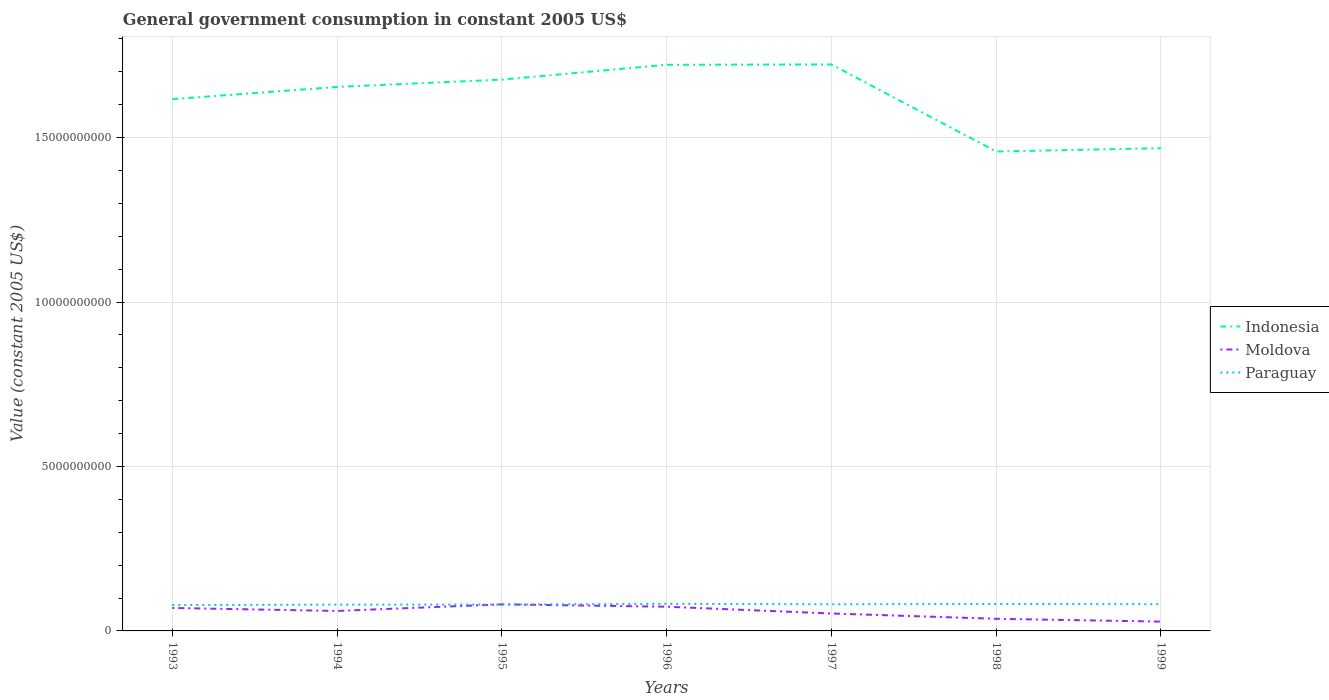How many different coloured lines are there?
Your answer should be compact. 3. Across all years, what is the maximum government conusmption in Moldova?
Give a very brief answer. 2.83e+08. In which year was the government conusmption in Indonesia maximum?
Ensure brevity in your answer.  1998. What is the total government conusmption in Indonesia in the graph?
Provide a succinct answer. -5.95e+08. What is the difference between the highest and the second highest government conusmption in Paraguay?
Keep it short and to the point. 3.76e+07. How many legend labels are there?
Give a very brief answer. 3. What is the title of the graph?
Make the answer very short. General government consumption in constant 2005 US$. Does "South Sudan" appear as one of the legend labels in the graph?
Keep it short and to the point. No. What is the label or title of the X-axis?
Your answer should be compact. Years. What is the label or title of the Y-axis?
Keep it short and to the point. Value (constant 2005 US$). What is the Value (constant 2005 US$) in Indonesia in 1993?
Your answer should be compact. 1.62e+1. What is the Value (constant 2005 US$) in Moldova in 1993?
Provide a short and direct response. 6.98e+08. What is the Value (constant 2005 US$) in Paraguay in 1993?
Provide a short and direct response. 7.86e+08. What is the Value (constant 2005 US$) of Indonesia in 1994?
Provide a short and direct response. 1.65e+1. What is the Value (constant 2005 US$) of Moldova in 1994?
Offer a terse response. 6.08e+08. What is the Value (constant 2005 US$) of Paraguay in 1994?
Your answer should be very brief. 8.00e+08. What is the Value (constant 2005 US$) in Indonesia in 1995?
Make the answer very short. 1.68e+1. What is the Value (constant 2005 US$) in Moldova in 1995?
Offer a very short reply. 8.07e+08. What is the Value (constant 2005 US$) of Paraguay in 1995?
Offer a terse response. 8.02e+08. What is the Value (constant 2005 US$) of Indonesia in 1996?
Make the answer very short. 1.72e+1. What is the Value (constant 2005 US$) in Moldova in 1996?
Your answer should be compact. 7.36e+08. What is the Value (constant 2005 US$) in Paraguay in 1996?
Your answer should be compact. 8.23e+08. What is the Value (constant 2005 US$) of Indonesia in 1997?
Offer a terse response. 1.72e+1. What is the Value (constant 2005 US$) of Moldova in 1997?
Your response must be concise. 5.30e+08. What is the Value (constant 2005 US$) of Paraguay in 1997?
Your answer should be compact. 8.10e+08. What is the Value (constant 2005 US$) of Indonesia in 1998?
Provide a short and direct response. 1.46e+1. What is the Value (constant 2005 US$) of Moldova in 1998?
Make the answer very short. 3.69e+08. What is the Value (constant 2005 US$) in Paraguay in 1998?
Give a very brief answer. 8.19e+08. What is the Value (constant 2005 US$) of Indonesia in 1999?
Offer a very short reply. 1.47e+1. What is the Value (constant 2005 US$) of Moldova in 1999?
Ensure brevity in your answer.  2.83e+08. What is the Value (constant 2005 US$) of Paraguay in 1999?
Ensure brevity in your answer.  8.12e+08. Across all years, what is the maximum Value (constant 2005 US$) in Indonesia?
Offer a very short reply. 1.72e+1. Across all years, what is the maximum Value (constant 2005 US$) in Moldova?
Provide a short and direct response. 8.07e+08. Across all years, what is the maximum Value (constant 2005 US$) of Paraguay?
Offer a very short reply. 8.23e+08. Across all years, what is the minimum Value (constant 2005 US$) of Indonesia?
Give a very brief answer. 1.46e+1. Across all years, what is the minimum Value (constant 2005 US$) in Moldova?
Keep it short and to the point. 2.83e+08. Across all years, what is the minimum Value (constant 2005 US$) of Paraguay?
Your answer should be compact. 7.86e+08. What is the total Value (constant 2005 US$) of Indonesia in the graph?
Offer a very short reply. 1.13e+11. What is the total Value (constant 2005 US$) of Moldova in the graph?
Offer a terse response. 4.03e+09. What is the total Value (constant 2005 US$) of Paraguay in the graph?
Give a very brief answer. 5.65e+09. What is the difference between the Value (constant 2005 US$) in Indonesia in 1993 and that in 1994?
Provide a short and direct response. -3.73e+08. What is the difference between the Value (constant 2005 US$) of Moldova in 1993 and that in 1994?
Your answer should be compact. 9.04e+07. What is the difference between the Value (constant 2005 US$) of Paraguay in 1993 and that in 1994?
Your answer should be very brief. -1.39e+07. What is the difference between the Value (constant 2005 US$) in Indonesia in 1993 and that in 1995?
Your response must be concise. -5.95e+08. What is the difference between the Value (constant 2005 US$) of Moldova in 1993 and that in 1995?
Offer a terse response. -1.09e+08. What is the difference between the Value (constant 2005 US$) of Paraguay in 1993 and that in 1995?
Your answer should be compact. -1.62e+07. What is the difference between the Value (constant 2005 US$) in Indonesia in 1993 and that in 1996?
Make the answer very short. -1.05e+09. What is the difference between the Value (constant 2005 US$) of Moldova in 1993 and that in 1996?
Your response must be concise. -3.82e+07. What is the difference between the Value (constant 2005 US$) of Paraguay in 1993 and that in 1996?
Make the answer very short. -3.76e+07. What is the difference between the Value (constant 2005 US$) in Indonesia in 1993 and that in 1997?
Keep it short and to the point. -1.06e+09. What is the difference between the Value (constant 2005 US$) of Moldova in 1993 and that in 1997?
Keep it short and to the point. 1.68e+08. What is the difference between the Value (constant 2005 US$) of Paraguay in 1993 and that in 1997?
Your answer should be compact. -2.44e+07. What is the difference between the Value (constant 2005 US$) in Indonesia in 1993 and that in 1998?
Offer a very short reply. 1.59e+09. What is the difference between the Value (constant 2005 US$) in Moldova in 1993 and that in 1998?
Ensure brevity in your answer.  3.29e+08. What is the difference between the Value (constant 2005 US$) of Paraguay in 1993 and that in 1998?
Provide a short and direct response. -3.36e+07. What is the difference between the Value (constant 2005 US$) of Indonesia in 1993 and that in 1999?
Ensure brevity in your answer.  1.49e+09. What is the difference between the Value (constant 2005 US$) in Moldova in 1993 and that in 1999?
Ensure brevity in your answer.  4.15e+08. What is the difference between the Value (constant 2005 US$) of Paraguay in 1993 and that in 1999?
Offer a terse response. -2.66e+07. What is the difference between the Value (constant 2005 US$) in Indonesia in 1994 and that in 1995?
Your response must be concise. -2.22e+08. What is the difference between the Value (constant 2005 US$) of Moldova in 1994 and that in 1995?
Your response must be concise. -2.00e+08. What is the difference between the Value (constant 2005 US$) in Paraguay in 1994 and that in 1995?
Your answer should be compact. -2.36e+06. What is the difference between the Value (constant 2005 US$) in Indonesia in 1994 and that in 1996?
Make the answer very short. -6.73e+08. What is the difference between the Value (constant 2005 US$) in Moldova in 1994 and that in 1996?
Provide a short and direct response. -1.29e+08. What is the difference between the Value (constant 2005 US$) in Paraguay in 1994 and that in 1996?
Your response must be concise. -2.37e+07. What is the difference between the Value (constant 2005 US$) of Indonesia in 1994 and that in 1997?
Keep it short and to the point. -6.84e+08. What is the difference between the Value (constant 2005 US$) in Moldova in 1994 and that in 1997?
Provide a succinct answer. 7.75e+07. What is the difference between the Value (constant 2005 US$) of Paraguay in 1994 and that in 1997?
Keep it short and to the point. -1.05e+07. What is the difference between the Value (constant 2005 US$) of Indonesia in 1994 and that in 1998?
Offer a very short reply. 1.96e+09. What is the difference between the Value (constant 2005 US$) in Moldova in 1994 and that in 1998?
Offer a terse response. 2.39e+08. What is the difference between the Value (constant 2005 US$) in Paraguay in 1994 and that in 1998?
Provide a short and direct response. -1.97e+07. What is the difference between the Value (constant 2005 US$) of Indonesia in 1994 and that in 1999?
Your answer should be compact. 1.86e+09. What is the difference between the Value (constant 2005 US$) of Moldova in 1994 and that in 1999?
Keep it short and to the point. 3.24e+08. What is the difference between the Value (constant 2005 US$) in Paraguay in 1994 and that in 1999?
Your answer should be compact. -1.28e+07. What is the difference between the Value (constant 2005 US$) of Indonesia in 1995 and that in 1996?
Provide a succinct answer. -4.51e+08. What is the difference between the Value (constant 2005 US$) of Moldova in 1995 and that in 1996?
Make the answer very short. 7.11e+07. What is the difference between the Value (constant 2005 US$) in Paraguay in 1995 and that in 1996?
Make the answer very short. -2.14e+07. What is the difference between the Value (constant 2005 US$) of Indonesia in 1995 and that in 1997?
Keep it short and to the point. -4.62e+08. What is the difference between the Value (constant 2005 US$) in Moldova in 1995 and that in 1997?
Your answer should be very brief. 2.77e+08. What is the difference between the Value (constant 2005 US$) in Paraguay in 1995 and that in 1997?
Provide a short and direct response. -8.18e+06. What is the difference between the Value (constant 2005 US$) of Indonesia in 1995 and that in 1998?
Make the answer very short. 2.19e+09. What is the difference between the Value (constant 2005 US$) in Moldova in 1995 and that in 1998?
Provide a succinct answer. 4.39e+08. What is the difference between the Value (constant 2005 US$) of Paraguay in 1995 and that in 1998?
Your response must be concise. -1.74e+07. What is the difference between the Value (constant 2005 US$) in Indonesia in 1995 and that in 1999?
Your response must be concise. 2.08e+09. What is the difference between the Value (constant 2005 US$) in Moldova in 1995 and that in 1999?
Provide a succinct answer. 5.24e+08. What is the difference between the Value (constant 2005 US$) of Paraguay in 1995 and that in 1999?
Your response must be concise. -1.04e+07. What is the difference between the Value (constant 2005 US$) of Indonesia in 1996 and that in 1997?
Your answer should be compact. -1.05e+07. What is the difference between the Value (constant 2005 US$) of Moldova in 1996 and that in 1997?
Give a very brief answer. 2.06e+08. What is the difference between the Value (constant 2005 US$) in Paraguay in 1996 and that in 1997?
Ensure brevity in your answer.  1.32e+07. What is the difference between the Value (constant 2005 US$) in Indonesia in 1996 and that in 1998?
Make the answer very short. 2.64e+09. What is the difference between the Value (constant 2005 US$) in Moldova in 1996 and that in 1998?
Give a very brief answer. 3.68e+08. What is the difference between the Value (constant 2005 US$) of Paraguay in 1996 and that in 1998?
Offer a very short reply. 4.01e+06. What is the difference between the Value (constant 2005 US$) in Indonesia in 1996 and that in 1999?
Your response must be concise. 2.54e+09. What is the difference between the Value (constant 2005 US$) of Moldova in 1996 and that in 1999?
Your response must be concise. 4.53e+08. What is the difference between the Value (constant 2005 US$) in Paraguay in 1996 and that in 1999?
Give a very brief answer. 1.10e+07. What is the difference between the Value (constant 2005 US$) of Indonesia in 1997 and that in 1998?
Your answer should be compact. 2.65e+09. What is the difference between the Value (constant 2005 US$) of Moldova in 1997 and that in 1998?
Your answer should be compact. 1.61e+08. What is the difference between the Value (constant 2005 US$) in Paraguay in 1997 and that in 1998?
Your response must be concise. -9.19e+06. What is the difference between the Value (constant 2005 US$) in Indonesia in 1997 and that in 1999?
Your response must be concise. 2.55e+09. What is the difference between the Value (constant 2005 US$) in Moldova in 1997 and that in 1999?
Provide a short and direct response. 2.47e+08. What is the difference between the Value (constant 2005 US$) of Paraguay in 1997 and that in 1999?
Provide a short and direct response. -2.23e+06. What is the difference between the Value (constant 2005 US$) of Indonesia in 1998 and that in 1999?
Give a very brief answer. -1.01e+08. What is the difference between the Value (constant 2005 US$) of Moldova in 1998 and that in 1999?
Your answer should be compact. 8.54e+07. What is the difference between the Value (constant 2005 US$) in Paraguay in 1998 and that in 1999?
Make the answer very short. 6.96e+06. What is the difference between the Value (constant 2005 US$) in Indonesia in 1993 and the Value (constant 2005 US$) in Moldova in 1994?
Your answer should be very brief. 1.56e+1. What is the difference between the Value (constant 2005 US$) in Indonesia in 1993 and the Value (constant 2005 US$) in Paraguay in 1994?
Your answer should be very brief. 1.54e+1. What is the difference between the Value (constant 2005 US$) of Moldova in 1993 and the Value (constant 2005 US$) of Paraguay in 1994?
Offer a terse response. -1.02e+08. What is the difference between the Value (constant 2005 US$) in Indonesia in 1993 and the Value (constant 2005 US$) in Moldova in 1995?
Your answer should be very brief. 1.54e+1. What is the difference between the Value (constant 2005 US$) in Indonesia in 1993 and the Value (constant 2005 US$) in Paraguay in 1995?
Offer a very short reply. 1.54e+1. What is the difference between the Value (constant 2005 US$) in Moldova in 1993 and the Value (constant 2005 US$) in Paraguay in 1995?
Your response must be concise. -1.04e+08. What is the difference between the Value (constant 2005 US$) of Indonesia in 1993 and the Value (constant 2005 US$) of Moldova in 1996?
Your answer should be compact. 1.54e+1. What is the difference between the Value (constant 2005 US$) of Indonesia in 1993 and the Value (constant 2005 US$) of Paraguay in 1996?
Make the answer very short. 1.53e+1. What is the difference between the Value (constant 2005 US$) in Moldova in 1993 and the Value (constant 2005 US$) in Paraguay in 1996?
Your answer should be very brief. -1.25e+08. What is the difference between the Value (constant 2005 US$) in Indonesia in 1993 and the Value (constant 2005 US$) in Moldova in 1997?
Provide a succinct answer. 1.56e+1. What is the difference between the Value (constant 2005 US$) of Indonesia in 1993 and the Value (constant 2005 US$) of Paraguay in 1997?
Your answer should be compact. 1.54e+1. What is the difference between the Value (constant 2005 US$) in Moldova in 1993 and the Value (constant 2005 US$) in Paraguay in 1997?
Your answer should be compact. -1.12e+08. What is the difference between the Value (constant 2005 US$) in Indonesia in 1993 and the Value (constant 2005 US$) in Moldova in 1998?
Your answer should be very brief. 1.58e+1. What is the difference between the Value (constant 2005 US$) of Indonesia in 1993 and the Value (constant 2005 US$) of Paraguay in 1998?
Offer a terse response. 1.54e+1. What is the difference between the Value (constant 2005 US$) in Moldova in 1993 and the Value (constant 2005 US$) in Paraguay in 1998?
Provide a succinct answer. -1.21e+08. What is the difference between the Value (constant 2005 US$) in Indonesia in 1993 and the Value (constant 2005 US$) in Moldova in 1999?
Provide a succinct answer. 1.59e+1. What is the difference between the Value (constant 2005 US$) of Indonesia in 1993 and the Value (constant 2005 US$) of Paraguay in 1999?
Provide a succinct answer. 1.54e+1. What is the difference between the Value (constant 2005 US$) in Moldova in 1993 and the Value (constant 2005 US$) in Paraguay in 1999?
Offer a terse response. -1.14e+08. What is the difference between the Value (constant 2005 US$) of Indonesia in 1994 and the Value (constant 2005 US$) of Moldova in 1995?
Offer a very short reply. 1.57e+1. What is the difference between the Value (constant 2005 US$) in Indonesia in 1994 and the Value (constant 2005 US$) in Paraguay in 1995?
Offer a terse response. 1.57e+1. What is the difference between the Value (constant 2005 US$) in Moldova in 1994 and the Value (constant 2005 US$) in Paraguay in 1995?
Offer a terse response. -1.94e+08. What is the difference between the Value (constant 2005 US$) of Indonesia in 1994 and the Value (constant 2005 US$) of Moldova in 1996?
Your answer should be very brief. 1.58e+1. What is the difference between the Value (constant 2005 US$) of Indonesia in 1994 and the Value (constant 2005 US$) of Paraguay in 1996?
Give a very brief answer. 1.57e+1. What is the difference between the Value (constant 2005 US$) in Moldova in 1994 and the Value (constant 2005 US$) in Paraguay in 1996?
Offer a very short reply. -2.16e+08. What is the difference between the Value (constant 2005 US$) in Indonesia in 1994 and the Value (constant 2005 US$) in Moldova in 1997?
Give a very brief answer. 1.60e+1. What is the difference between the Value (constant 2005 US$) of Indonesia in 1994 and the Value (constant 2005 US$) of Paraguay in 1997?
Give a very brief answer. 1.57e+1. What is the difference between the Value (constant 2005 US$) in Moldova in 1994 and the Value (constant 2005 US$) in Paraguay in 1997?
Your answer should be very brief. -2.03e+08. What is the difference between the Value (constant 2005 US$) in Indonesia in 1994 and the Value (constant 2005 US$) in Moldova in 1998?
Make the answer very short. 1.62e+1. What is the difference between the Value (constant 2005 US$) of Indonesia in 1994 and the Value (constant 2005 US$) of Paraguay in 1998?
Your answer should be very brief. 1.57e+1. What is the difference between the Value (constant 2005 US$) of Moldova in 1994 and the Value (constant 2005 US$) of Paraguay in 1998?
Ensure brevity in your answer.  -2.12e+08. What is the difference between the Value (constant 2005 US$) in Indonesia in 1994 and the Value (constant 2005 US$) in Moldova in 1999?
Provide a short and direct response. 1.63e+1. What is the difference between the Value (constant 2005 US$) of Indonesia in 1994 and the Value (constant 2005 US$) of Paraguay in 1999?
Provide a short and direct response. 1.57e+1. What is the difference between the Value (constant 2005 US$) of Moldova in 1994 and the Value (constant 2005 US$) of Paraguay in 1999?
Make the answer very short. -2.05e+08. What is the difference between the Value (constant 2005 US$) of Indonesia in 1995 and the Value (constant 2005 US$) of Moldova in 1996?
Ensure brevity in your answer.  1.60e+1. What is the difference between the Value (constant 2005 US$) of Indonesia in 1995 and the Value (constant 2005 US$) of Paraguay in 1996?
Offer a very short reply. 1.59e+1. What is the difference between the Value (constant 2005 US$) in Moldova in 1995 and the Value (constant 2005 US$) in Paraguay in 1996?
Your response must be concise. -1.60e+07. What is the difference between the Value (constant 2005 US$) of Indonesia in 1995 and the Value (constant 2005 US$) of Moldova in 1997?
Give a very brief answer. 1.62e+1. What is the difference between the Value (constant 2005 US$) in Indonesia in 1995 and the Value (constant 2005 US$) in Paraguay in 1997?
Your response must be concise. 1.60e+1. What is the difference between the Value (constant 2005 US$) of Moldova in 1995 and the Value (constant 2005 US$) of Paraguay in 1997?
Offer a terse response. -2.84e+06. What is the difference between the Value (constant 2005 US$) in Indonesia in 1995 and the Value (constant 2005 US$) in Moldova in 1998?
Your response must be concise. 1.64e+1. What is the difference between the Value (constant 2005 US$) of Indonesia in 1995 and the Value (constant 2005 US$) of Paraguay in 1998?
Make the answer very short. 1.59e+1. What is the difference between the Value (constant 2005 US$) in Moldova in 1995 and the Value (constant 2005 US$) in Paraguay in 1998?
Ensure brevity in your answer.  -1.20e+07. What is the difference between the Value (constant 2005 US$) of Indonesia in 1995 and the Value (constant 2005 US$) of Moldova in 1999?
Your answer should be compact. 1.65e+1. What is the difference between the Value (constant 2005 US$) of Indonesia in 1995 and the Value (constant 2005 US$) of Paraguay in 1999?
Make the answer very short. 1.60e+1. What is the difference between the Value (constant 2005 US$) of Moldova in 1995 and the Value (constant 2005 US$) of Paraguay in 1999?
Provide a short and direct response. -5.07e+06. What is the difference between the Value (constant 2005 US$) of Indonesia in 1996 and the Value (constant 2005 US$) of Moldova in 1997?
Give a very brief answer. 1.67e+1. What is the difference between the Value (constant 2005 US$) in Indonesia in 1996 and the Value (constant 2005 US$) in Paraguay in 1997?
Your answer should be compact. 1.64e+1. What is the difference between the Value (constant 2005 US$) in Moldova in 1996 and the Value (constant 2005 US$) in Paraguay in 1997?
Make the answer very short. -7.40e+07. What is the difference between the Value (constant 2005 US$) of Indonesia in 1996 and the Value (constant 2005 US$) of Moldova in 1998?
Give a very brief answer. 1.68e+1. What is the difference between the Value (constant 2005 US$) of Indonesia in 1996 and the Value (constant 2005 US$) of Paraguay in 1998?
Offer a very short reply. 1.64e+1. What is the difference between the Value (constant 2005 US$) in Moldova in 1996 and the Value (constant 2005 US$) in Paraguay in 1998?
Provide a succinct answer. -8.32e+07. What is the difference between the Value (constant 2005 US$) of Indonesia in 1996 and the Value (constant 2005 US$) of Moldova in 1999?
Ensure brevity in your answer.  1.69e+1. What is the difference between the Value (constant 2005 US$) in Indonesia in 1996 and the Value (constant 2005 US$) in Paraguay in 1999?
Offer a very short reply. 1.64e+1. What is the difference between the Value (constant 2005 US$) in Moldova in 1996 and the Value (constant 2005 US$) in Paraguay in 1999?
Your answer should be compact. -7.62e+07. What is the difference between the Value (constant 2005 US$) of Indonesia in 1997 and the Value (constant 2005 US$) of Moldova in 1998?
Make the answer very short. 1.69e+1. What is the difference between the Value (constant 2005 US$) in Indonesia in 1997 and the Value (constant 2005 US$) in Paraguay in 1998?
Offer a very short reply. 1.64e+1. What is the difference between the Value (constant 2005 US$) of Moldova in 1997 and the Value (constant 2005 US$) of Paraguay in 1998?
Make the answer very short. -2.89e+08. What is the difference between the Value (constant 2005 US$) in Indonesia in 1997 and the Value (constant 2005 US$) in Moldova in 1999?
Keep it short and to the point. 1.69e+1. What is the difference between the Value (constant 2005 US$) of Indonesia in 1997 and the Value (constant 2005 US$) of Paraguay in 1999?
Offer a terse response. 1.64e+1. What is the difference between the Value (constant 2005 US$) of Moldova in 1997 and the Value (constant 2005 US$) of Paraguay in 1999?
Your response must be concise. -2.82e+08. What is the difference between the Value (constant 2005 US$) in Indonesia in 1998 and the Value (constant 2005 US$) in Moldova in 1999?
Offer a terse response. 1.43e+1. What is the difference between the Value (constant 2005 US$) in Indonesia in 1998 and the Value (constant 2005 US$) in Paraguay in 1999?
Your answer should be very brief. 1.38e+1. What is the difference between the Value (constant 2005 US$) in Moldova in 1998 and the Value (constant 2005 US$) in Paraguay in 1999?
Make the answer very short. -4.44e+08. What is the average Value (constant 2005 US$) in Indonesia per year?
Offer a very short reply. 1.62e+1. What is the average Value (constant 2005 US$) in Moldova per year?
Ensure brevity in your answer.  5.76e+08. What is the average Value (constant 2005 US$) in Paraguay per year?
Provide a short and direct response. 8.08e+08. In the year 1993, what is the difference between the Value (constant 2005 US$) in Indonesia and Value (constant 2005 US$) in Moldova?
Offer a terse response. 1.55e+1. In the year 1993, what is the difference between the Value (constant 2005 US$) in Indonesia and Value (constant 2005 US$) in Paraguay?
Provide a short and direct response. 1.54e+1. In the year 1993, what is the difference between the Value (constant 2005 US$) of Moldova and Value (constant 2005 US$) of Paraguay?
Keep it short and to the point. -8.78e+07. In the year 1994, what is the difference between the Value (constant 2005 US$) in Indonesia and Value (constant 2005 US$) in Moldova?
Your answer should be very brief. 1.59e+1. In the year 1994, what is the difference between the Value (constant 2005 US$) of Indonesia and Value (constant 2005 US$) of Paraguay?
Offer a terse response. 1.57e+1. In the year 1994, what is the difference between the Value (constant 2005 US$) in Moldova and Value (constant 2005 US$) in Paraguay?
Make the answer very short. -1.92e+08. In the year 1995, what is the difference between the Value (constant 2005 US$) of Indonesia and Value (constant 2005 US$) of Moldova?
Your response must be concise. 1.60e+1. In the year 1995, what is the difference between the Value (constant 2005 US$) of Indonesia and Value (constant 2005 US$) of Paraguay?
Offer a terse response. 1.60e+1. In the year 1995, what is the difference between the Value (constant 2005 US$) in Moldova and Value (constant 2005 US$) in Paraguay?
Give a very brief answer. 5.33e+06. In the year 1996, what is the difference between the Value (constant 2005 US$) of Indonesia and Value (constant 2005 US$) of Moldova?
Provide a short and direct response. 1.65e+1. In the year 1996, what is the difference between the Value (constant 2005 US$) of Indonesia and Value (constant 2005 US$) of Paraguay?
Ensure brevity in your answer.  1.64e+1. In the year 1996, what is the difference between the Value (constant 2005 US$) in Moldova and Value (constant 2005 US$) in Paraguay?
Your answer should be compact. -8.72e+07. In the year 1997, what is the difference between the Value (constant 2005 US$) in Indonesia and Value (constant 2005 US$) in Moldova?
Your response must be concise. 1.67e+1. In the year 1997, what is the difference between the Value (constant 2005 US$) of Indonesia and Value (constant 2005 US$) of Paraguay?
Your answer should be compact. 1.64e+1. In the year 1997, what is the difference between the Value (constant 2005 US$) of Moldova and Value (constant 2005 US$) of Paraguay?
Provide a succinct answer. -2.80e+08. In the year 1998, what is the difference between the Value (constant 2005 US$) of Indonesia and Value (constant 2005 US$) of Moldova?
Keep it short and to the point. 1.42e+1. In the year 1998, what is the difference between the Value (constant 2005 US$) in Indonesia and Value (constant 2005 US$) in Paraguay?
Your answer should be very brief. 1.38e+1. In the year 1998, what is the difference between the Value (constant 2005 US$) in Moldova and Value (constant 2005 US$) in Paraguay?
Offer a terse response. -4.51e+08. In the year 1999, what is the difference between the Value (constant 2005 US$) of Indonesia and Value (constant 2005 US$) of Moldova?
Make the answer very short. 1.44e+1. In the year 1999, what is the difference between the Value (constant 2005 US$) of Indonesia and Value (constant 2005 US$) of Paraguay?
Ensure brevity in your answer.  1.39e+1. In the year 1999, what is the difference between the Value (constant 2005 US$) of Moldova and Value (constant 2005 US$) of Paraguay?
Make the answer very short. -5.29e+08. What is the ratio of the Value (constant 2005 US$) of Indonesia in 1993 to that in 1994?
Offer a very short reply. 0.98. What is the ratio of the Value (constant 2005 US$) in Moldova in 1993 to that in 1994?
Offer a terse response. 1.15. What is the ratio of the Value (constant 2005 US$) in Paraguay in 1993 to that in 1994?
Your answer should be compact. 0.98. What is the ratio of the Value (constant 2005 US$) in Indonesia in 1993 to that in 1995?
Provide a succinct answer. 0.96. What is the ratio of the Value (constant 2005 US$) in Moldova in 1993 to that in 1995?
Your answer should be compact. 0.86. What is the ratio of the Value (constant 2005 US$) of Paraguay in 1993 to that in 1995?
Give a very brief answer. 0.98. What is the ratio of the Value (constant 2005 US$) in Indonesia in 1993 to that in 1996?
Ensure brevity in your answer.  0.94. What is the ratio of the Value (constant 2005 US$) of Moldova in 1993 to that in 1996?
Your response must be concise. 0.95. What is the ratio of the Value (constant 2005 US$) of Paraguay in 1993 to that in 1996?
Keep it short and to the point. 0.95. What is the ratio of the Value (constant 2005 US$) of Indonesia in 1993 to that in 1997?
Offer a terse response. 0.94. What is the ratio of the Value (constant 2005 US$) in Moldova in 1993 to that in 1997?
Keep it short and to the point. 1.32. What is the ratio of the Value (constant 2005 US$) of Paraguay in 1993 to that in 1997?
Provide a succinct answer. 0.97. What is the ratio of the Value (constant 2005 US$) of Indonesia in 1993 to that in 1998?
Make the answer very short. 1.11. What is the ratio of the Value (constant 2005 US$) in Moldova in 1993 to that in 1998?
Provide a short and direct response. 1.89. What is the ratio of the Value (constant 2005 US$) in Paraguay in 1993 to that in 1998?
Make the answer very short. 0.96. What is the ratio of the Value (constant 2005 US$) in Indonesia in 1993 to that in 1999?
Provide a succinct answer. 1.1. What is the ratio of the Value (constant 2005 US$) of Moldova in 1993 to that in 1999?
Your answer should be compact. 2.46. What is the ratio of the Value (constant 2005 US$) in Paraguay in 1993 to that in 1999?
Your response must be concise. 0.97. What is the ratio of the Value (constant 2005 US$) in Indonesia in 1994 to that in 1995?
Your response must be concise. 0.99. What is the ratio of the Value (constant 2005 US$) of Moldova in 1994 to that in 1995?
Keep it short and to the point. 0.75. What is the ratio of the Value (constant 2005 US$) of Indonesia in 1994 to that in 1996?
Give a very brief answer. 0.96. What is the ratio of the Value (constant 2005 US$) in Moldova in 1994 to that in 1996?
Make the answer very short. 0.83. What is the ratio of the Value (constant 2005 US$) in Paraguay in 1994 to that in 1996?
Keep it short and to the point. 0.97. What is the ratio of the Value (constant 2005 US$) in Indonesia in 1994 to that in 1997?
Provide a short and direct response. 0.96. What is the ratio of the Value (constant 2005 US$) of Moldova in 1994 to that in 1997?
Ensure brevity in your answer.  1.15. What is the ratio of the Value (constant 2005 US$) of Indonesia in 1994 to that in 1998?
Your response must be concise. 1.13. What is the ratio of the Value (constant 2005 US$) in Moldova in 1994 to that in 1998?
Provide a succinct answer. 1.65. What is the ratio of the Value (constant 2005 US$) of Paraguay in 1994 to that in 1998?
Keep it short and to the point. 0.98. What is the ratio of the Value (constant 2005 US$) of Indonesia in 1994 to that in 1999?
Offer a very short reply. 1.13. What is the ratio of the Value (constant 2005 US$) of Moldova in 1994 to that in 1999?
Keep it short and to the point. 2.15. What is the ratio of the Value (constant 2005 US$) of Paraguay in 1994 to that in 1999?
Keep it short and to the point. 0.98. What is the ratio of the Value (constant 2005 US$) in Indonesia in 1995 to that in 1996?
Make the answer very short. 0.97. What is the ratio of the Value (constant 2005 US$) of Moldova in 1995 to that in 1996?
Your response must be concise. 1.1. What is the ratio of the Value (constant 2005 US$) of Paraguay in 1995 to that in 1996?
Offer a terse response. 0.97. What is the ratio of the Value (constant 2005 US$) in Indonesia in 1995 to that in 1997?
Ensure brevity in your answer.  0.97. What is the ratio of the Value (constant 2005 US$) of Moldova in 1995 to that in 1997?
Give a very brief answer. 1.52. What is the ratio of the Value (constant 2005 US$) of Paraguay in 1995 to that in 1997?
Offer a very short reply. 0.99. What is the ratio of the Value (constant 2005 US$) in Indonesia in 1995 to that in 1998?
Your answer should be very brief. 1.15. What is the ratio of the Value (constant 2005 US$) of Moldova in 1995 to that in 1998?
Ensure brevity in your answer.  2.19. What is the ratio of the Value (constant 2005 US$) of Paraguay in 1995 to that in 1998?
Keep it short and to the point. 0.98. What is the ratio of the Value (constant 2005 US$) of Indonesia in 1995 to that in 1999?
Provide a succinct answer. 1.14. What is the ratio of the Value (constant 2005 US$) of Moldova in 1995 to that in 1999?
Provide a short and direct response. 2.85. What is the ratio of the Value (constant 2005 US$) in Paraguay in 1995 to that in 1999?
Offer a terse response. 0.99. What is the ratio of the Value (constant 2005 US$) of Indonesia in 1996 to that in 1997?
Your answer should be very brief. 1. What is the ratio of the Value (constant 2005 US$) in Moldova in 1996 to that in 1997?
Your answer should be compact. 1.39. What is the ratio of the Value (constant 2005 US$) in Paraguay in 1996 to that in 1997?
Provide a succinct answer. 1.02. What is the ratio of the Value (constant 2005 US$) of Indonesia in 1996 to that in 1998?
Ensure brevity in your answer.  1.18. What is the ratio of the Value (constant 2005 US$) in Moldova in 1996 to that in 1998?
Ensure brevity in your answer.  2. What is the ratio of the Value (constant 2005 US$) in Indonesia in 1996 to that in 1999?
Ensure brevity in your answer.  1.17. What is the ratio of the Value (constant 2005 US$) of Moldova in 1996 to that in 1999?
Your response must be concise. 2.6. What is the ratio of the Value (constant 2005 US$) of Paraguay in 1996 to that in 1999?
Offer a very short reply. 1.01. What is the ratio of the Value (constant 2005 US$) in Indonesia in 1997 to that in 1998?
Offer a terse response. 1.18. What is the ratio of the Value (constant 2005 US$) in Moldova in 1997 to that in 1998?
Your response must be concise. 1.44. What is the ratio of the Value (constant 2005 US$) of Paraguay in 1997 to that in 1998?
Your answer should be compact. 0.99. What is the ratio of the Value (constant 2005 US$) in Indonesia in 1997 to that in 1999?
Your answer should be compact. 1.17. What is the ratio of the Value (constant 2005 US$) in Moldova in 1997 to that in 1999?
Keep it short and to the point. 1.87. What is the ratio of the Value (constant 2005 US$) of Moldova in 1998 to that in 1999?
Your response must be concise. 1.3. What is the ratio of the Value (constant 2005 US$) in Paraguay in 1998 to that in 1999?
Give a very brief answer. 1.01. What is the difference between the highest and the second highest Value (constant 2005 US$) of Indonesia?
Make the answer very short. 1.05e+07. What is the difference between the highest and the second highest Value (constant 2005 US$) of Moldova?
Your answer should be compact. 7.11e+07. What is the difference between the highest and the second highest Value (constant 2005 US$) of Paraguay?
Ensure brevity in your answer.  4.01e+06. What is the difference between the highest and the lowest Value (constant 2005 US$) of Indonesia?
Provide a succinct answer. 2.65e+09. What is the difference between the highest and the lowest Value (constant 2005 US$) of Moldova?
Give a very brief answer. 5.24e+08. What is the difference between the highest and the lowest Value (constant 2005 US$) of Paraguay?
Offer a terse response. 3.76e+07. 